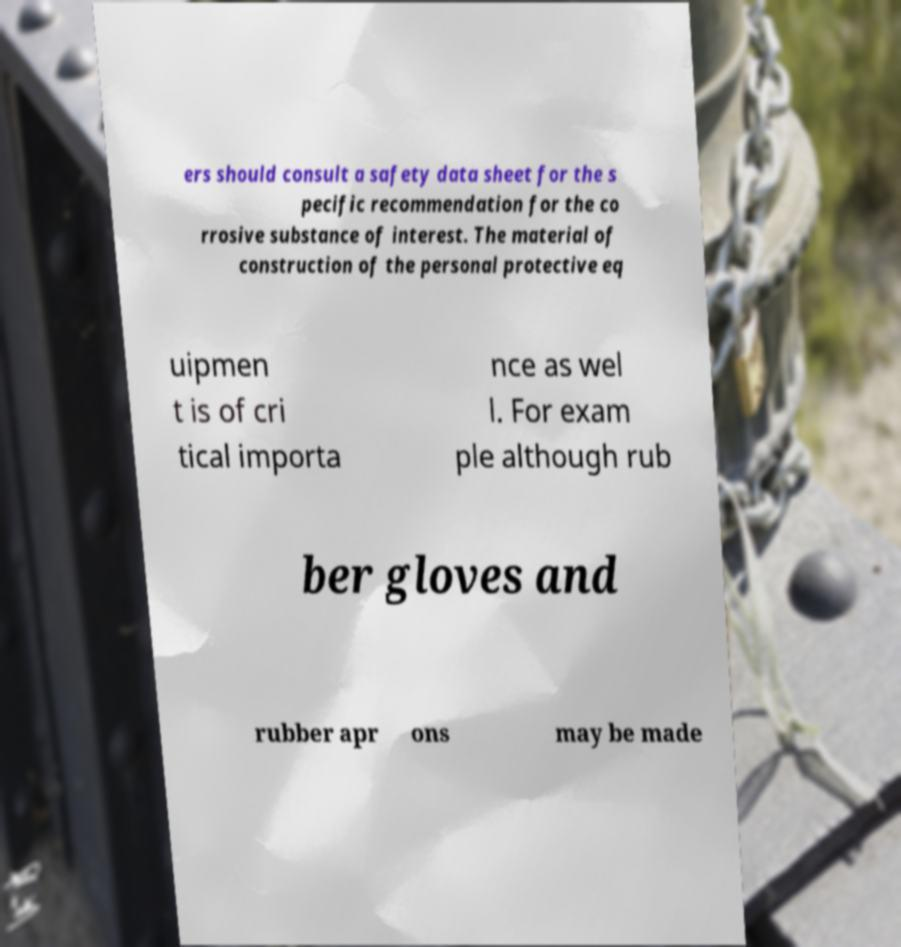Can you accurately transcribe the text from the provided image for me? ers should consult a safety data sheet for the s pecific recommendation for the co rrosive substance of interest. The material of construction of the personal protective eq uipmen t is of cri tical importa nce as wel l. For exam ple although rub ber gloves and rubber apr ons may be made 